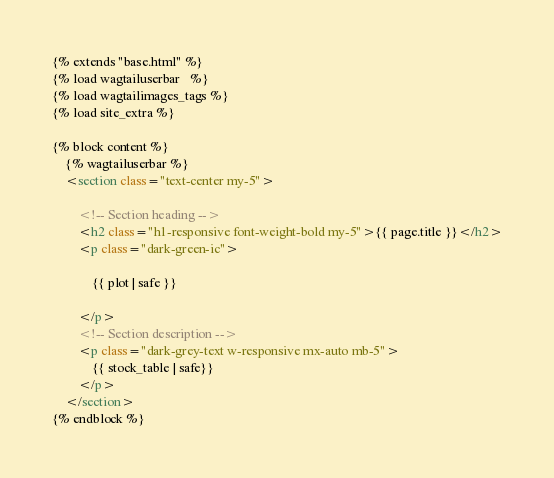<code> <loc_0><loc_0><loc_500><loc_500><_HTML_>
{% extends "base.html" %}
{% load wagtailuserbar   %}
{% load wagtailimages_tags %}
{% load site_extra %}

{% block content %}
    {% wagtailuserbar %}
    <section class="text-center my-5">

        <!-- Section heading -->
        <h2 class="h1-responsive font-weight-bold my-5">{{ page.title }}</h2>
        <p class="dark-green-ic">

            {{ plot | safe }}

        </p>
        <!-- Section description -->
        <p class="dark-grey-text w-responsive mx-auto mb-5">
            {{ stock_table | safe}}
        </p>
    </section>
{% endblock %}
</code> 